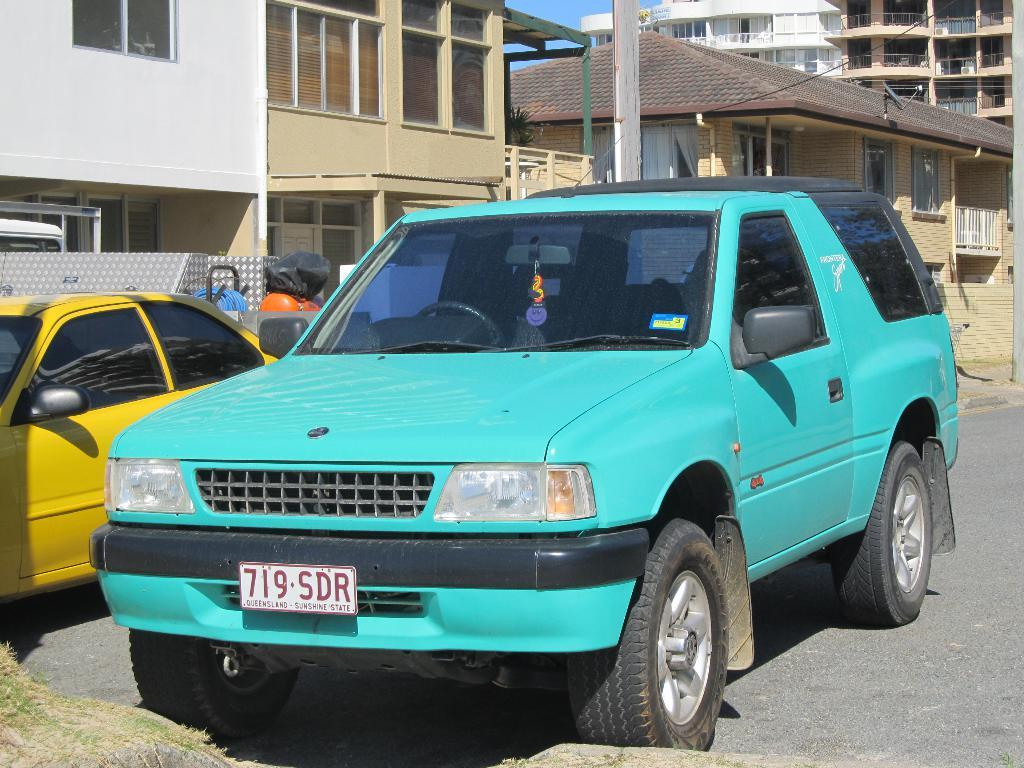<image>
Create a compact narrative representing the image presented. Blue vehicle that has Queensland sunshine state on the front license plate. 